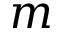Convert formula to latex. <formula><loc_0><loc_0><loc_500><loc_500>m</formula> 